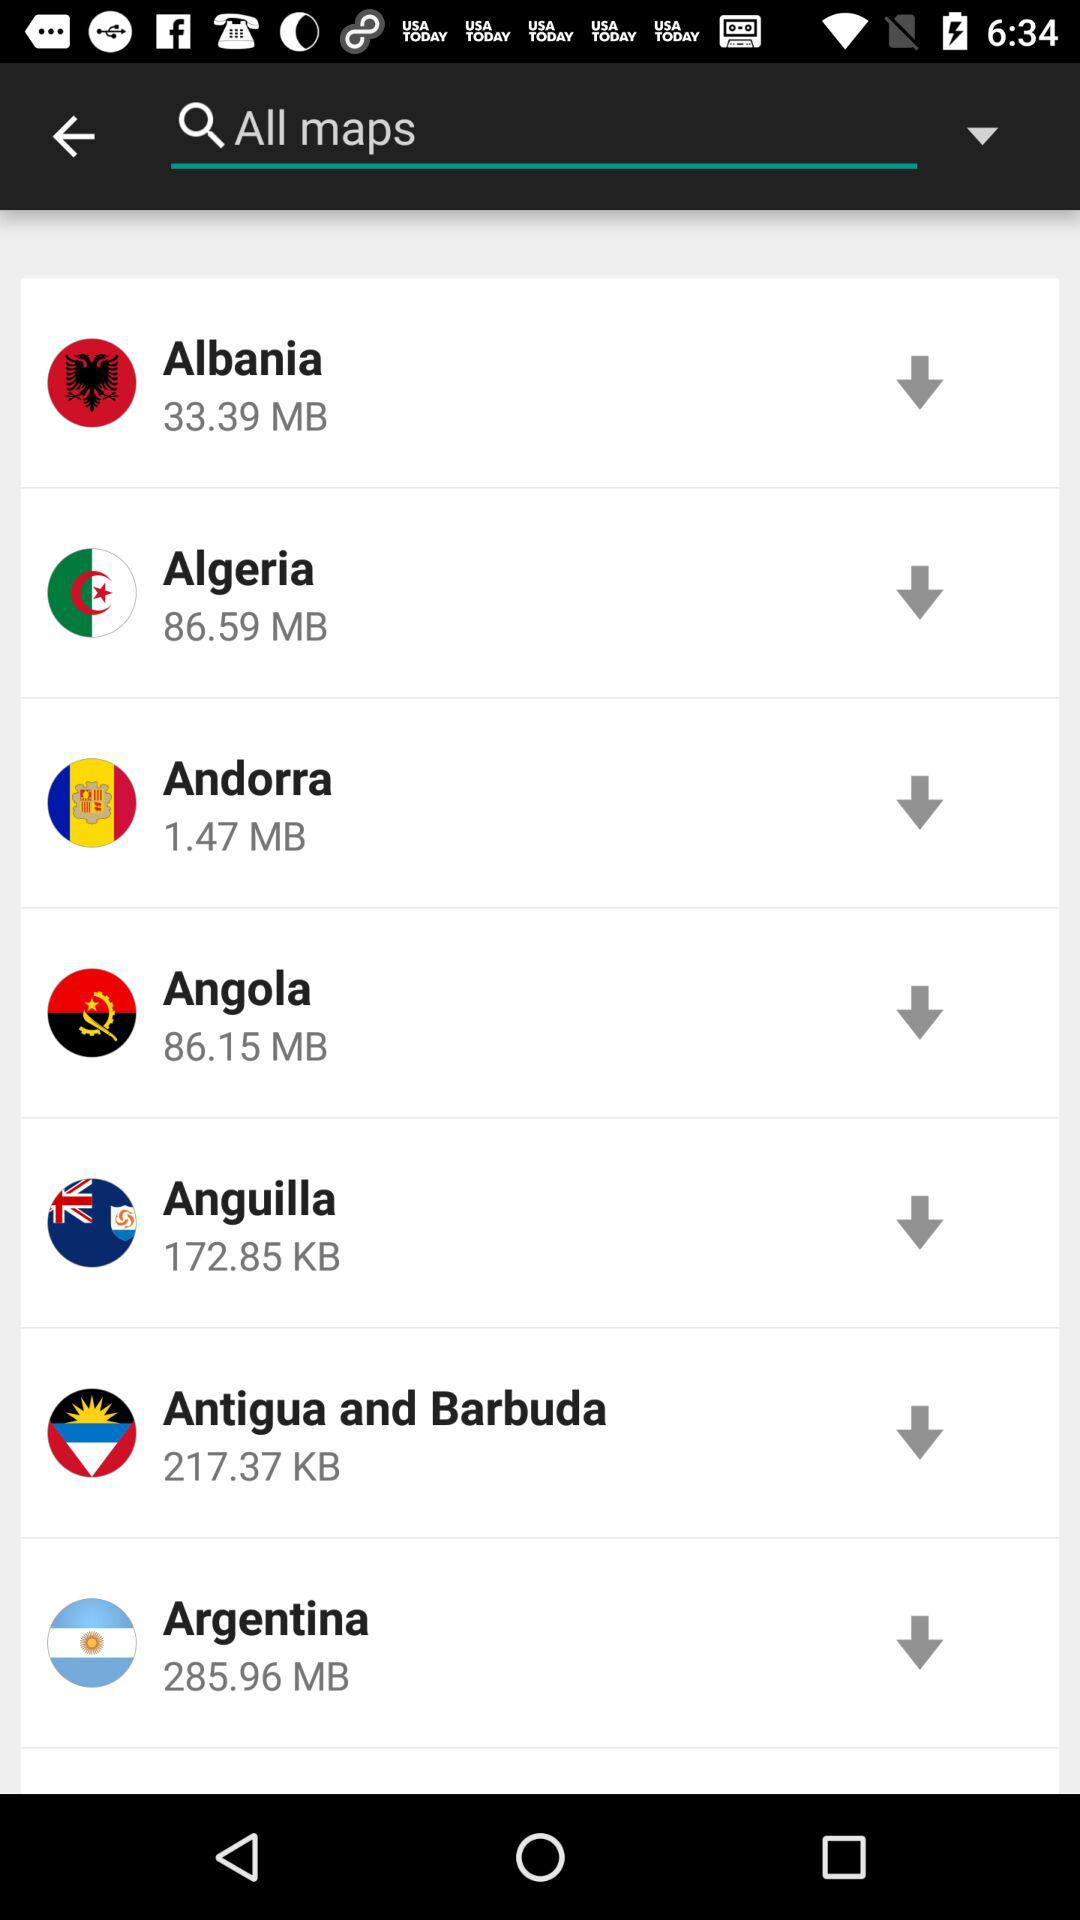What is the size of the "Angola" file? The size of the "Angola" file is 86.15 MB. 